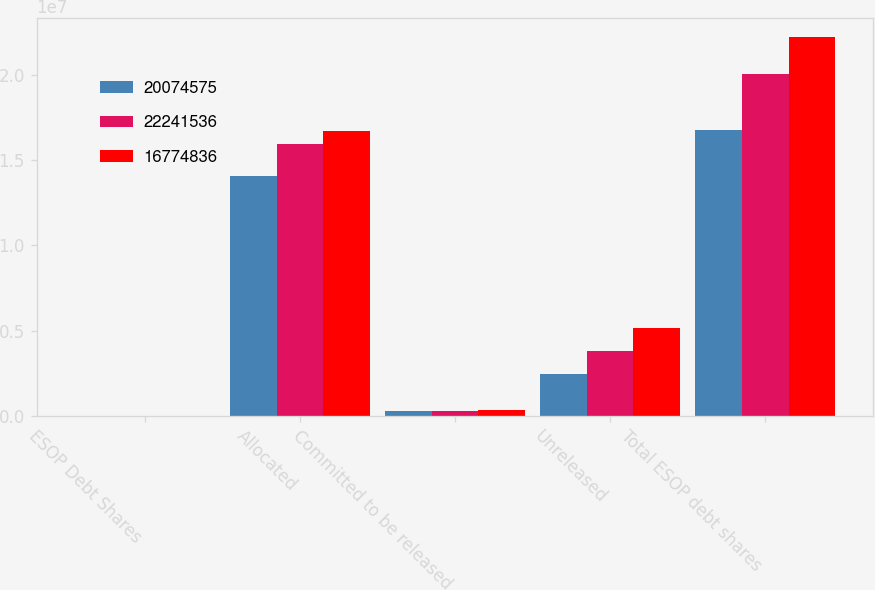Convert chart to OTSL. <chart><loc_0><loc_0><loc_500><loc_500><stacked_bar_chart><ecel><fcel>ESOP Debt Shares<fcel>Allocated<fcel>Committed to be released<fcel>Unreleased<fcel>Total ESOP debt shares<nl><fcel>2.00746e+07<fcel>2007<fcel>1.40391e+07<fcel>278125<fcel>2.45764e+06<fcel>1.67748e+07<nl><fcel>2.22415e+07<fcel>2006<fcel>1.59565e+07<fcel>286620<fcel>3.83142e+06<fcel>2.00746e+07<nl><fcel>1.67748e+07<fcel>2005<fcel>1.67295e+07<fcel>366969<fcel>5.14504e+06<fcel>2.22415e+07<nl></chart> 